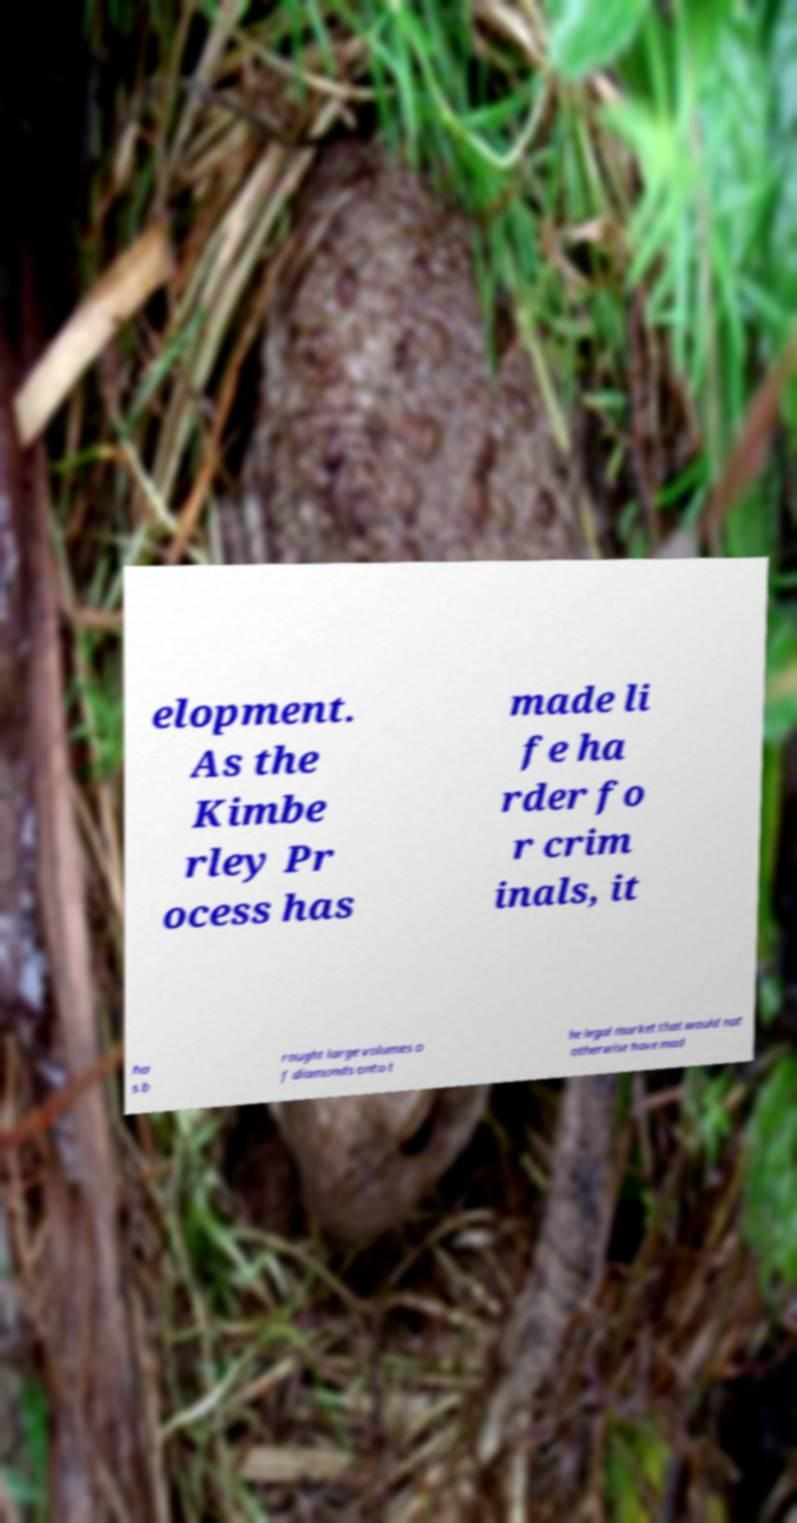Can you read and provide the text displayed in the image?This photo seems to have some interesting text. Can you extract and type it out for me? elopment. As the Kimbe rley Pr ocess has made li fe ha rder fo r crim inals, it ha s b rought large volumes o f diamonds onto t he legal market that would not otherwise have mad 